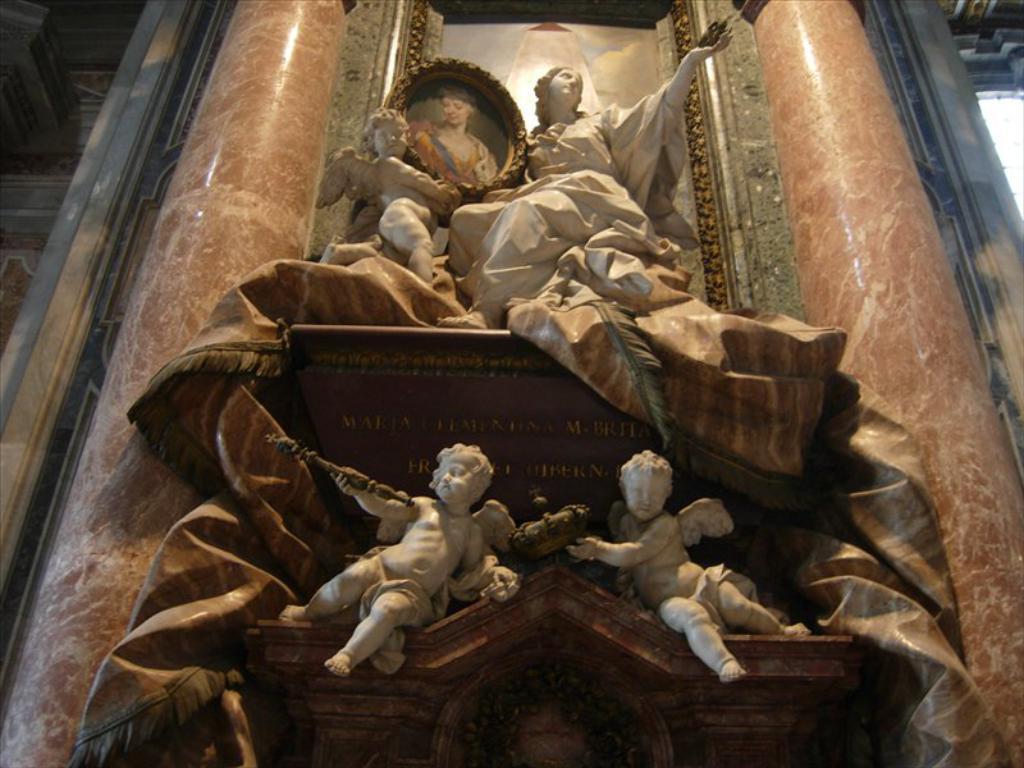How would you summarize this image in a sentence or two? In this image I see the sculptures over here which are of cream in color and I see that there are few words written over here and I see the pillars and I see a frame over here and I see the wall. 